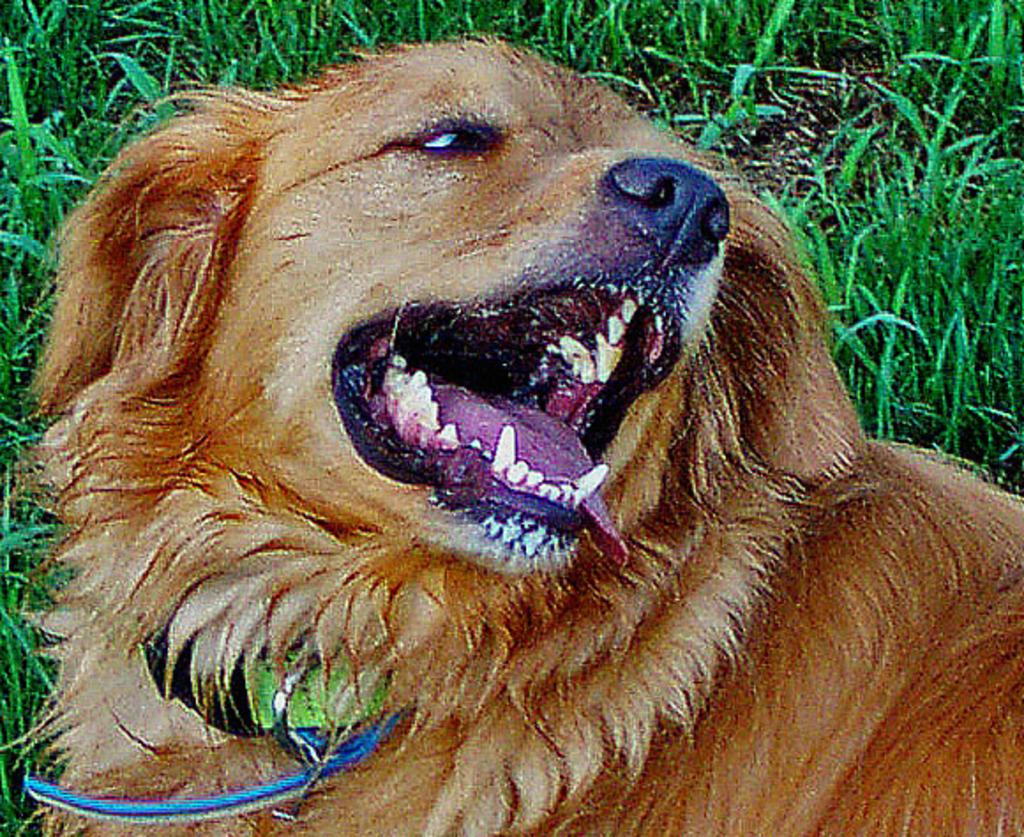What type of animal is in the image? There is a dog in the image. Can you describe the dog's appearance? The dog has a cream and brown color. What is the dog wearing in the image? The dog is wearing a blue color neck belt. What can be seen in the background of the image? There is grass in the background of the image. How many muscles does the crow have in the image? There is no crow present in the image, so it is not possible to determine the number of muscles it might have. 